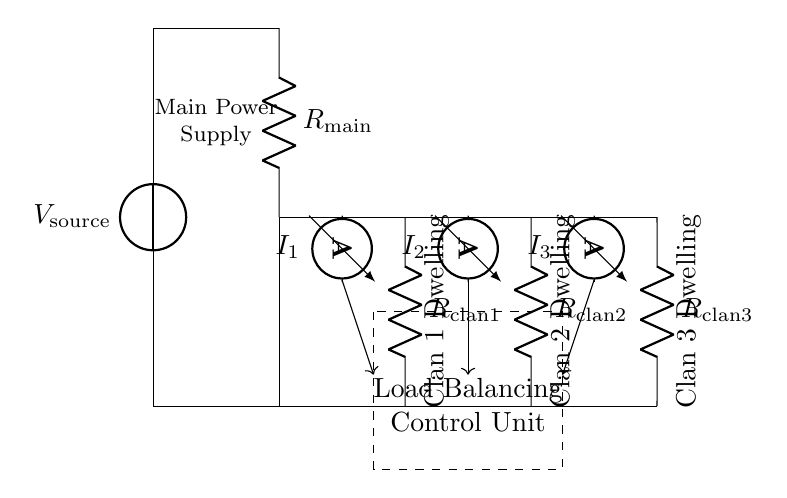What is the type of current flow in this circuit? The current flow in this circuit is direct current, indicated by the presence of a voltage source and resistors arranged in parallel. The current is divided among the loads connected to the source.
Answer: Direct current How many clans are represented in this circuit? The circuit diagram shows three clans represented by three resistors labeled for each clan; thus, there are three clans.
Answer: Three What is the function of the control unit in this circuit? The control unit's function is to manage the load balancing among the clans by monitoring the current flowing through each and adjusting as necessary to ensure equitable power sharing.
Answer: Load balancing Which component measures the current for clan 2? The component that measures the current for clan 2 is an ammeter placed in series with the resistor for clan 2, labeled as I2.
Answer: Ammeter In a current divider, how does the current distribute between the clans? The current distributes inversely proportional to the resistance of each clan's load; so, if one clan has a lower resistance, it will receive a greater share of the total current from the source.
Answer: Inversely proportional to resistance What is represented by the dashed rectangle in the circuit? The dashed rectangle in the circuit represents the control unit, which is responsible for load balancing between the clans by processing current readings from the ammeters.
Answer: Control unit What is the purpose of the feedback lines in this circuit? The feedback lines are used to send current measurements from each ammeter back to the control unit, allowing it to make adjustments for equitable power sharing among the clans.
Answer: Current measurements 